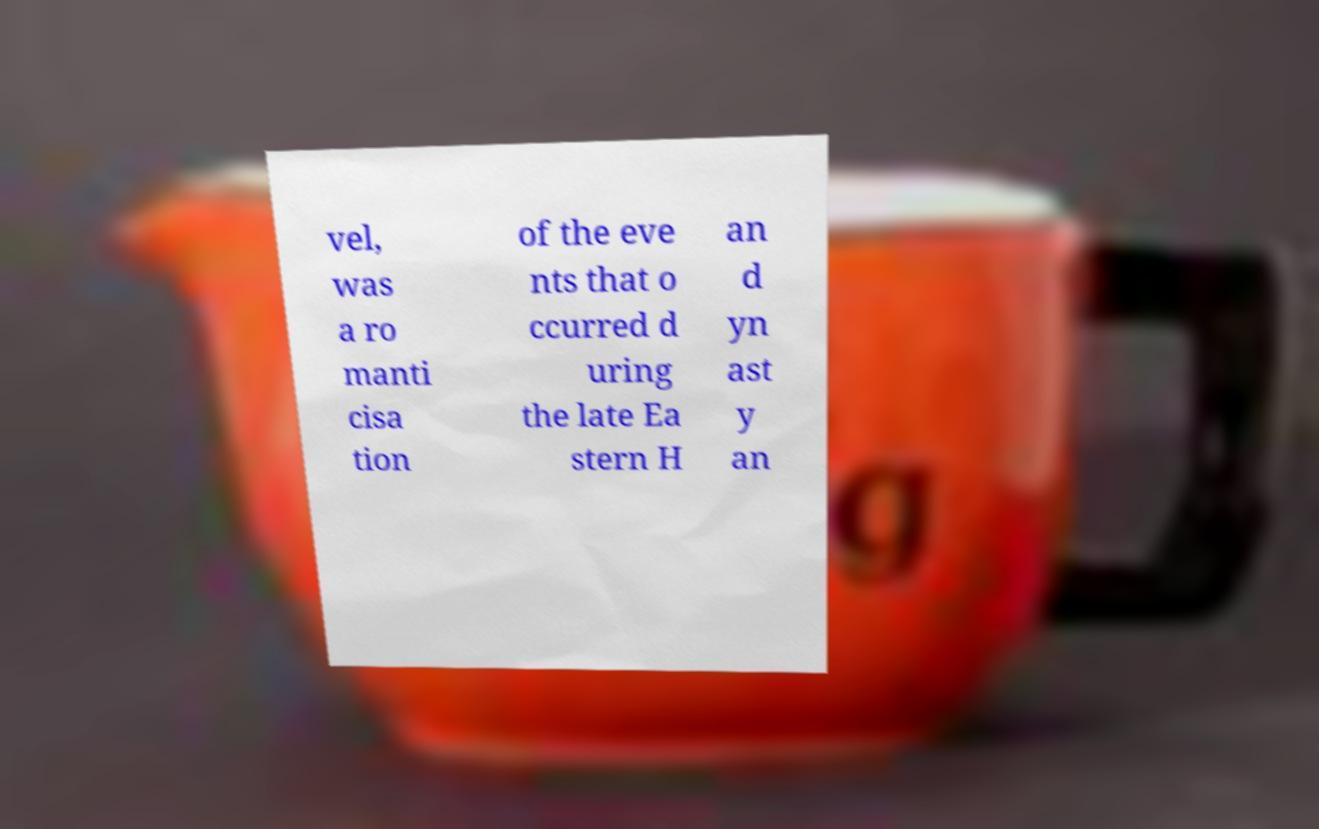For documentation purposes, I need the text within this image transcribed. Could you provide that? vel, was a ro manti cisa tion of the eve nts that o ccurred d uring the late Ea stern H an d yn ast y an 